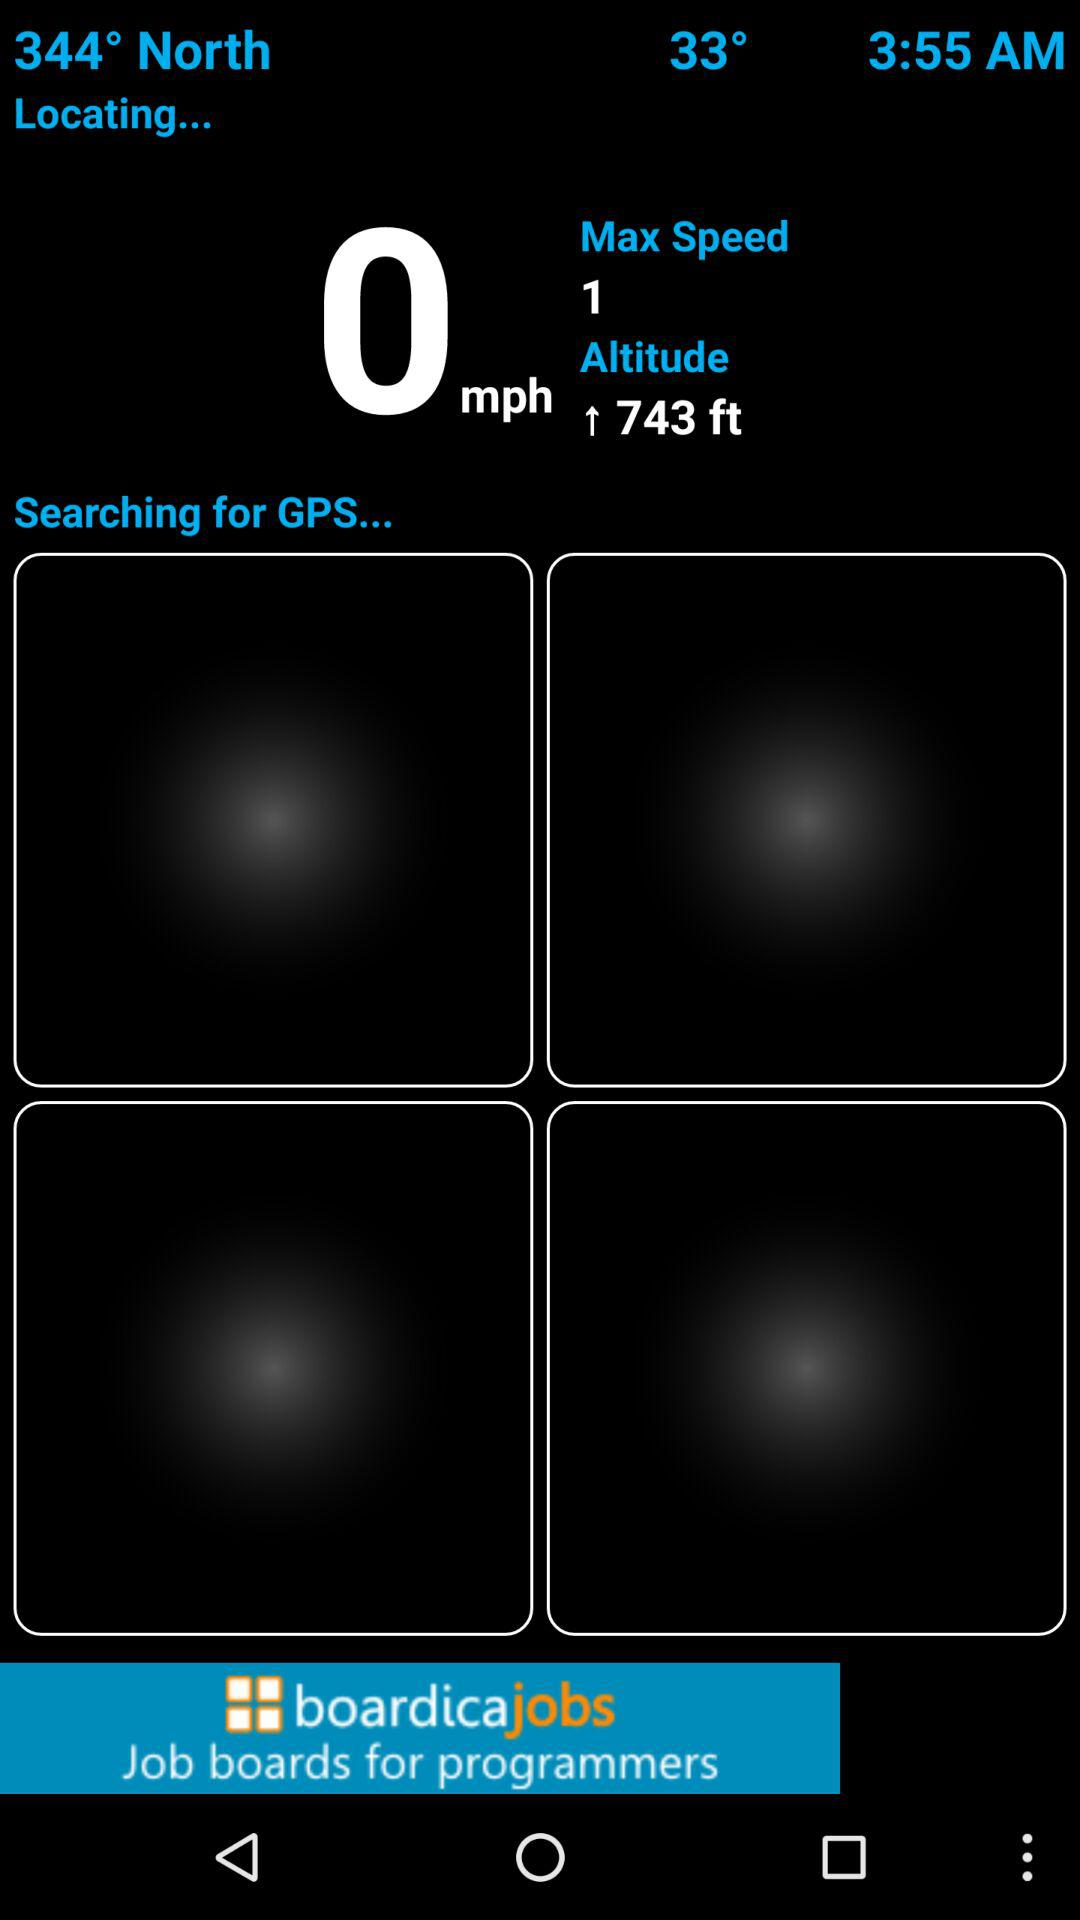What is the maximum speed? The maximum speed is 1. 